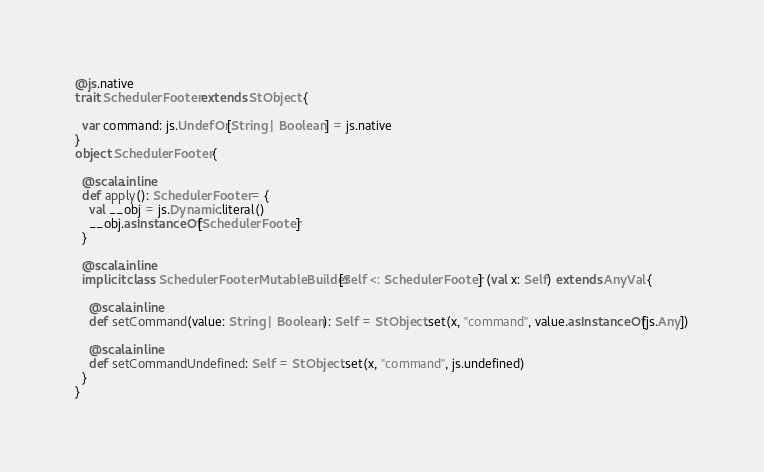<code> <loc_0><loc_0><loc_500><loc_500><_Scala_>@js.native
trait SchedulerFooter extends StObject {
  
  var command: js.UndefOr[String | Boolean] = js.native
}
object SchedulerFooter {
  
  @scala.inline
  def apply(): SchedulerFooter = {
    val __obj = js.Dynamic.literal()
    __obj.asInstanceOf[SchedulerFooter]
  }
  
  @scala.inline
  implicit class SchedulerFooterMutableBuilder[Self <: SchedulerFooter] (val x: Self) extends AnyVal {
    
    @scala.inline
    def setCommand(value: String | Boolean): Self = StObject.set(x, "command", value.asInstanceOf[js.Any])
    
    @scala.inline
    def setCommandUndefined: Self = StObject.set(x, "command", js.undefined)
  }
}
</code> 